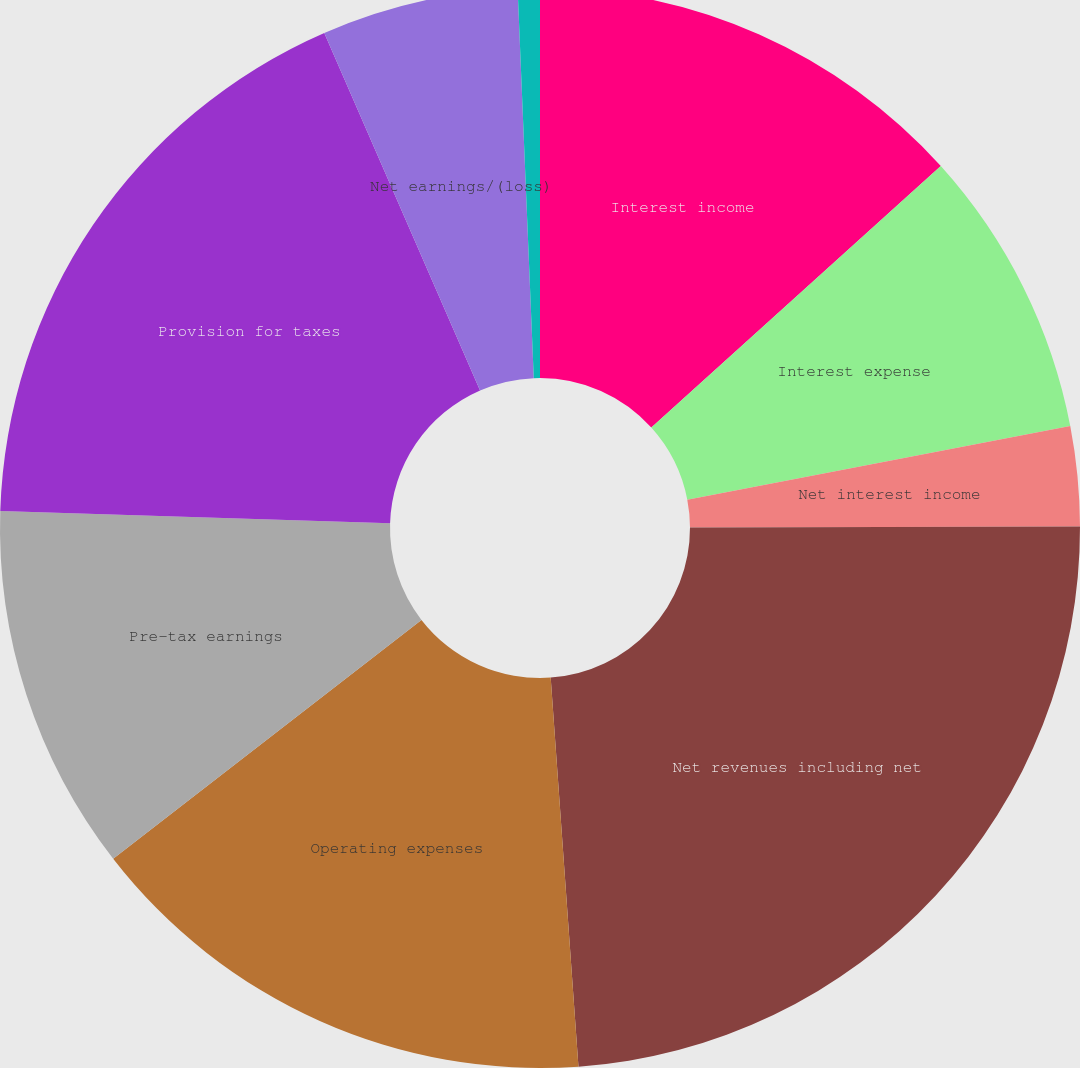Convert chart. <chart><loc_0><loc_0><loc_500><loc_500><pie_chart><fcel>Interest income<fcel>Interest expense<fcel>Net interest income<fcel>Net revenues including net<fcel>Operating expenses<fcel>Pre-tax earnings<fcel>Provision for taxes<fcel>Net earnings/(loss)<fcel>Preferred stock dividends<nl><fcel>13.31%<fcel>8.66%<fcel>2.98%<fcel>23.91%<fcel>15.64%<fcel>10.99%<fcel>17.96%<fcel>5.88%<fcel>0.66%<nl></chart> 